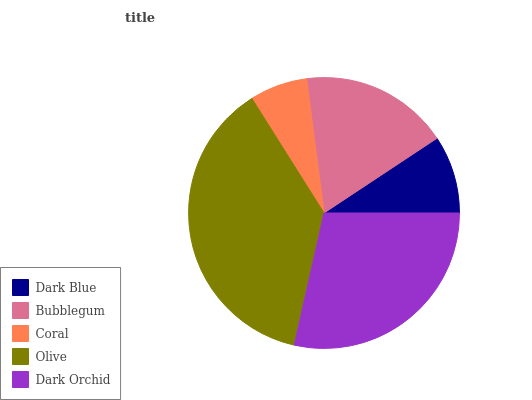Is Coral the minimum?
Answer yes or no. Yes. Is Olive the maximum?
Answer yes or no. Yes. Is Bubblegum the minimum?
Answer yes or no. No. Is Bubblegum the maximum?
Answer yes or no. No. Is Bubblegum greater than Dark Blue?
Answer yes or no. Yes. Is Dark Blue less than Bubblegum?
Answer yes or no. Yes. Is Dark Blue greater than Bubblegum?
Answer yes or no. No. Is Bubblegum less than Dark Blue?
Answer yes or no. No. Is Bubblegum the high median?
Answer yes or no. Yes. Is Bubblegum the low median?
Answer yes or no. Yes. Is Olive the high median?
Answer yes or no. No. Is Olive the low median?
Answer yes or no. No. 